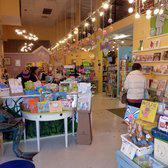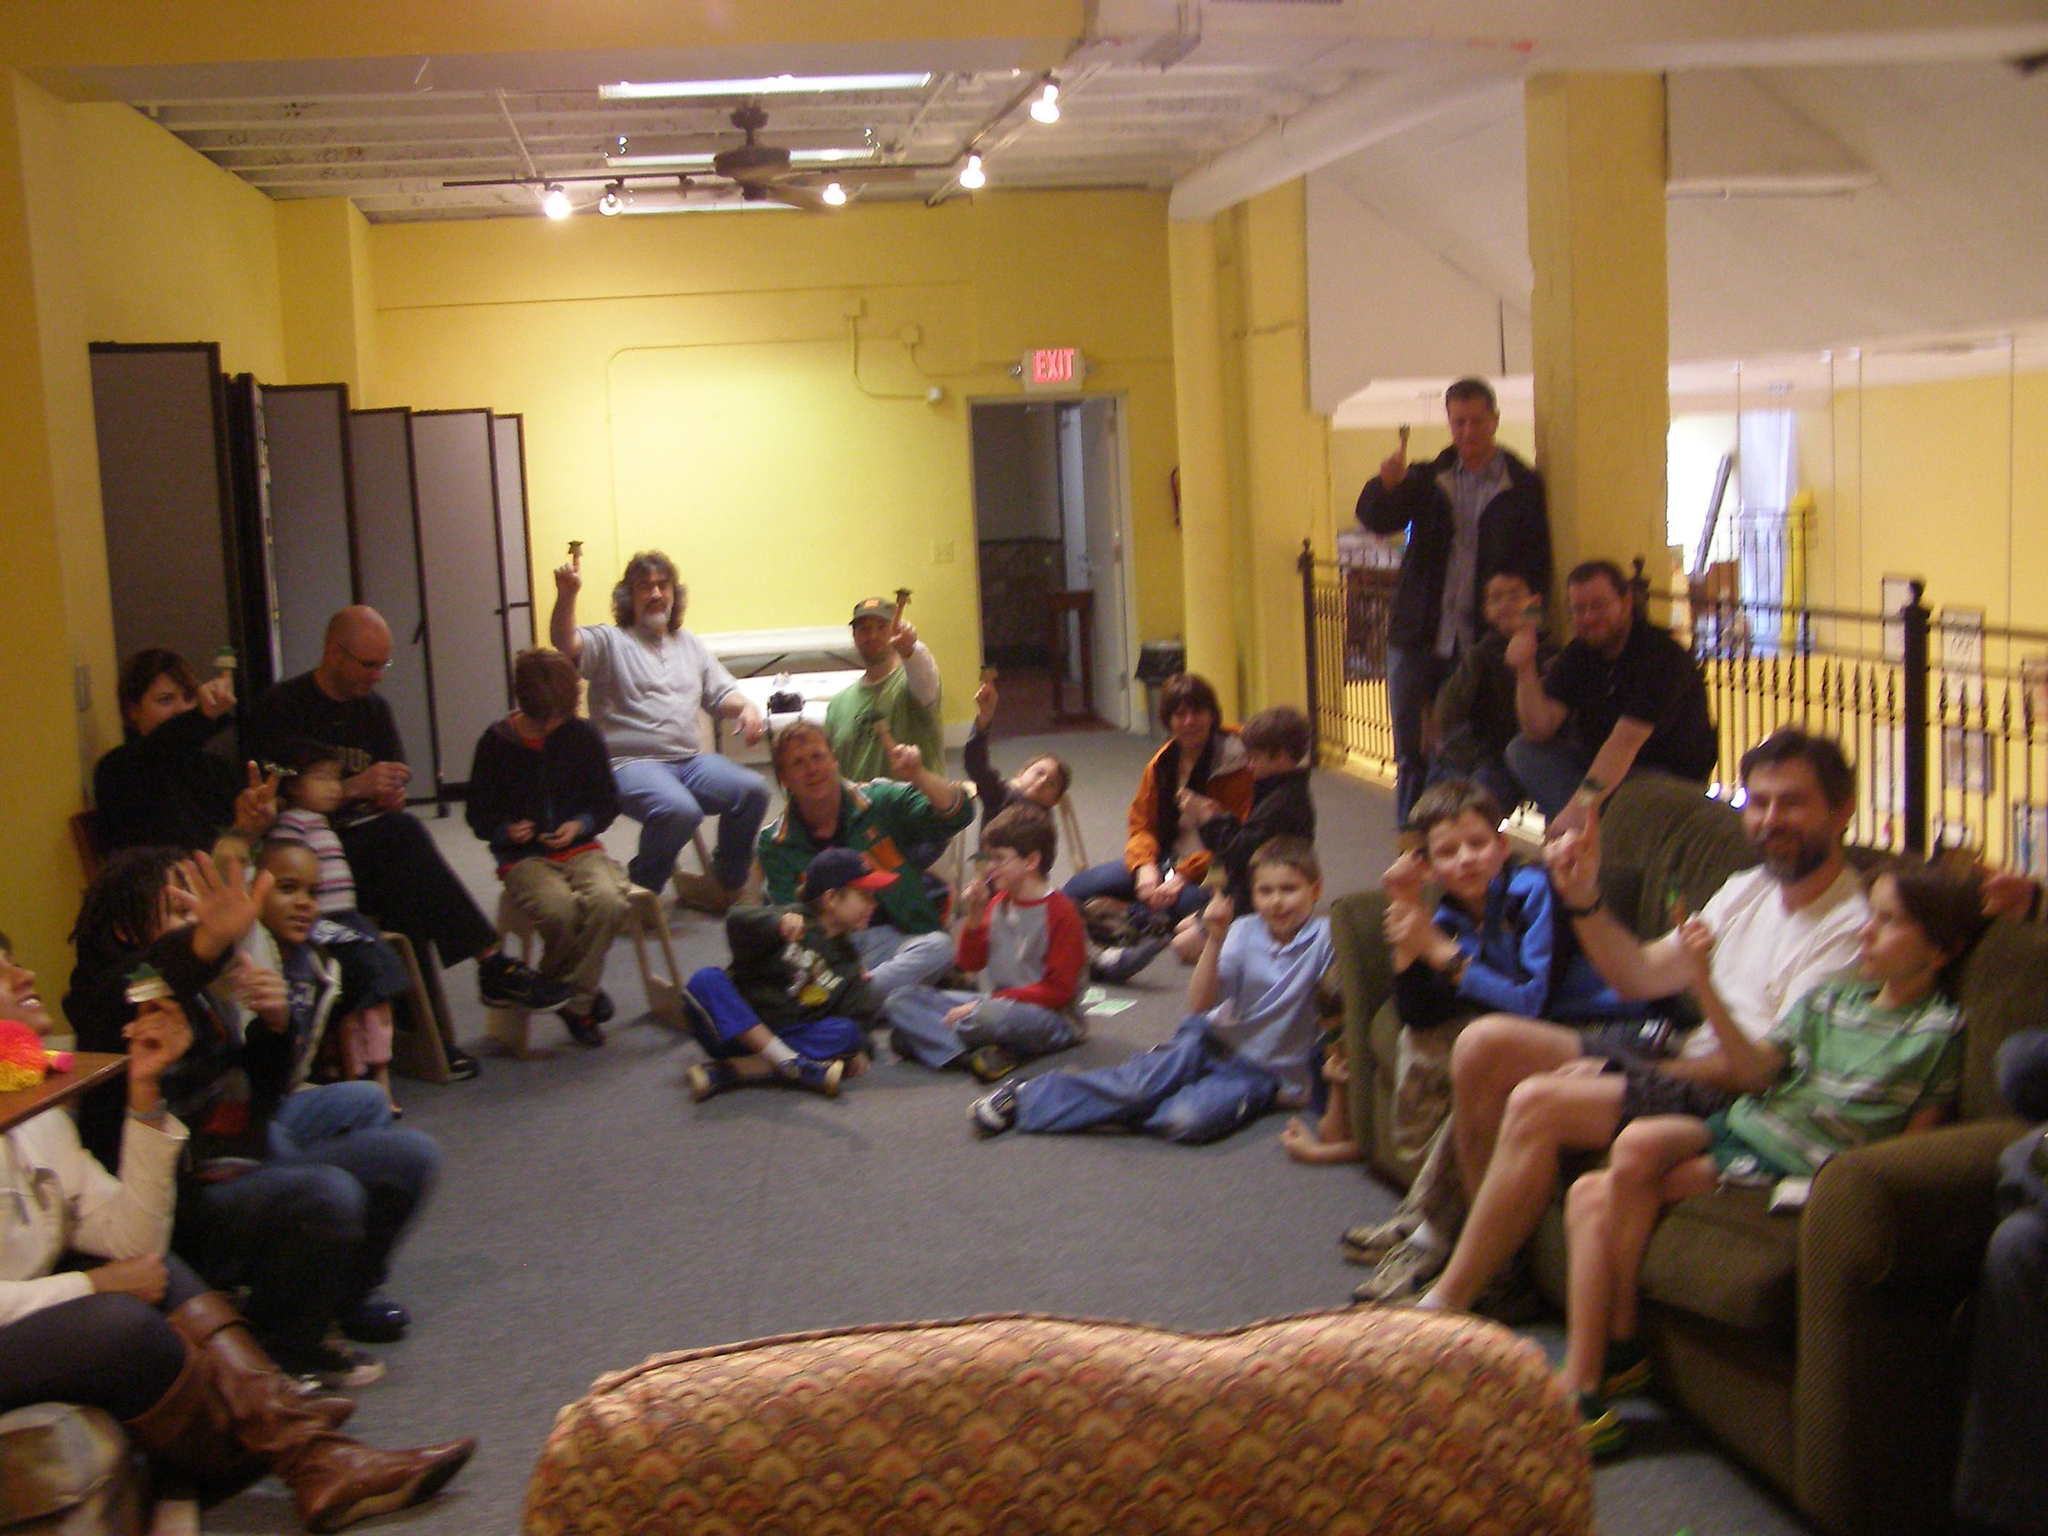The first image is the image on the left, the second image is the image on the right. Assess this claim about the two images: "One image shows a back-turned person standing in front of shelves at the right of the scene, and the other image includes at least one person sitting with a leg extended on the floor and back to the right.". Correct or not? Answer yes or no. Yes. 